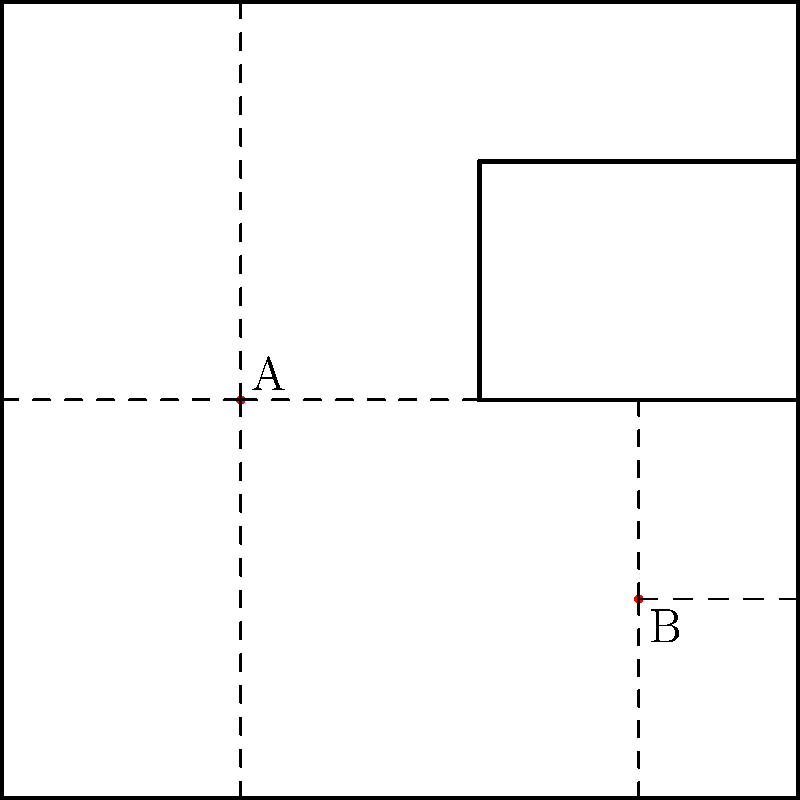In the Westworld control room, security chief Ashley Stubbs needs to optimize the surveillance system. The floor plan above represents a section of the Delos facility. Two cameras, A and B, are placed at the coordinates (30, 50) and (80, 25) respectively. What is the total area covered by these two cameras, assuming they can view in all directions but cannot see through walls? To solve this problem, we'll follow these steps:

1) First, we need to understand that each camera creates a visibility region bounded by the walls.

2) For Camera A at (30, 50):
   - It covers a rectangular area from x = 0 to x = 60
   - It covers the full height from y = 0 to y = 100
   - Area covered by A = $60 \times 100 = 6000$ square units

3) For Camera B at (80, 25):
   - It covers a rectangular area from x = 60 to x = 100
   - It covers from y = 0 to y = 50
   - Area covered by B = $40 \times 50 = 2000$ square units

4) The total area covered is the sum of these two areas:
   Total Area = Area A + Area B
               = $6000 + 2000 = 8000$ square units

5) This solution ensures maximum coverage without overlap, reminiscent of the efficient design of the Westworld park itself.
Answer: 8000 square units 